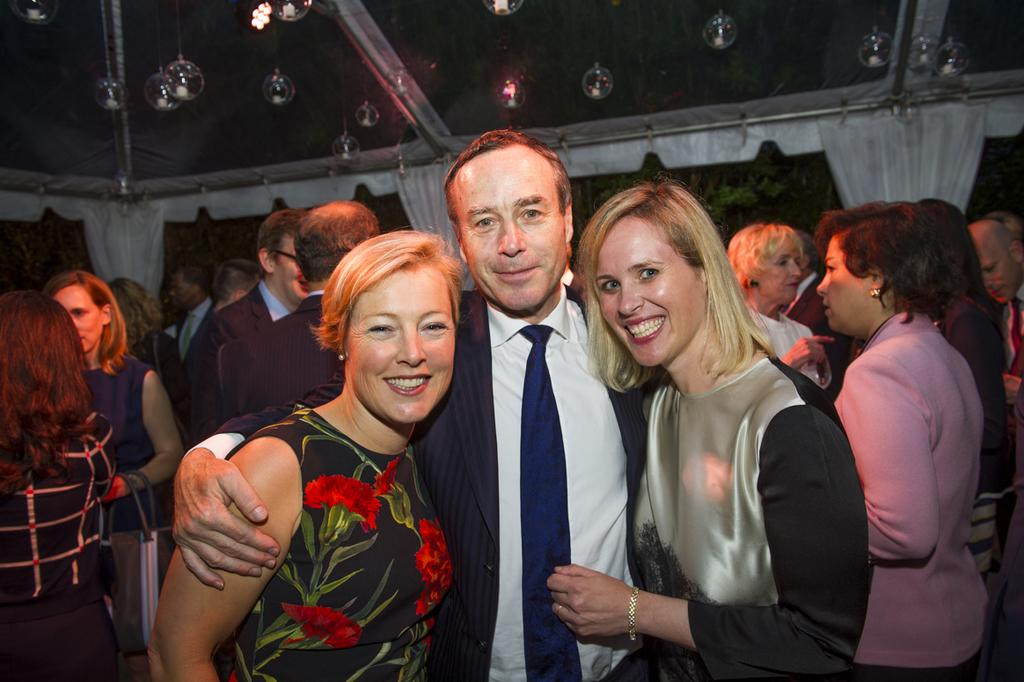How many people are in the group visible in the image? There is a group of people in the image, but the exact number cannot be determined from the provided facts. What is located behind the group of people in the image? There is a wall in the image behind the group of people. What type of window treatment is present in the image? There are white color curtains in the image. What is present in the image that appears to be floating or lightweight? There are bubbles in the image, which are typically lightweight and can float. Can you see any elbows in the image? There is no specific mention of elbows in the provided facts, so it cannot be determined if any are visible in the image. Is there a trail leading to the group of people in the image? There is no mention of a trail in the provided facts, so it cannot be determined if one is present in the image. 